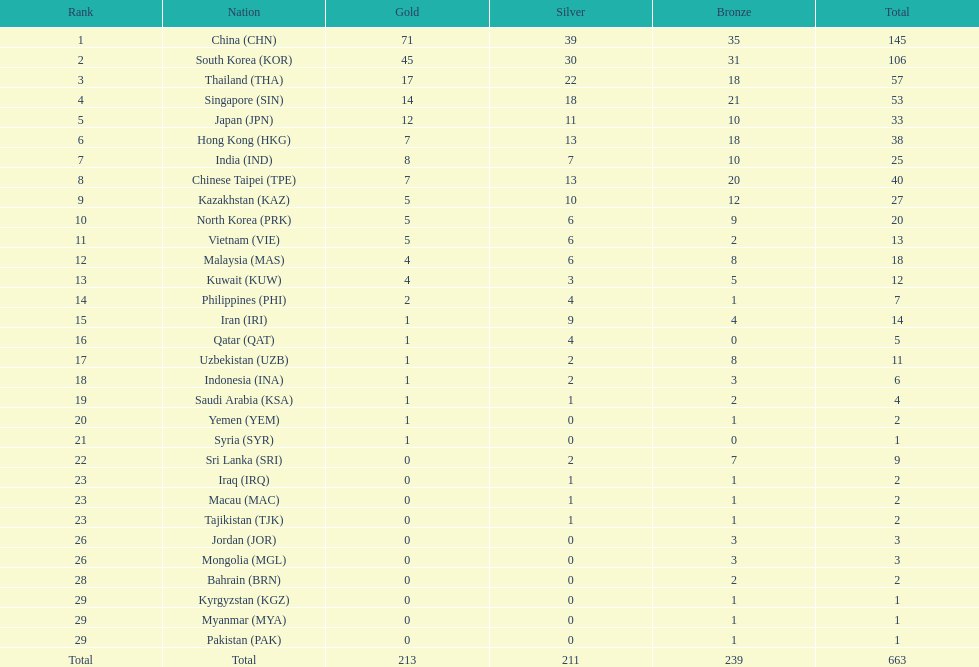Parse the full table. {'header': ['Rank', 'Nation', 'Gold', 'Silver', 'Bronze', 'Total'], 'rows': [['1', 'China\xa0(CHN)', '71', '39', '35', '145'], ['2', 'South Korea\xa0(KOR)', '45', '30', '31', '106'], ['3', 'Thailand\xa0(THA)', '17', '22', '18', '57'], ['4', 'Singapore\xa0(SIN)', '14', '18', '21', '53'], ['5', 'Japan\xa0(JPN)', '12', '11', '10', '33'], ['6', 'Hong Kong\xa0(HKG)', '7', '13', '18', '38'], ['7', 'India\xa0(IND)', '8', '7', '10', '25'], ['8', 'Chinese Taipei\xa0(TPE)', '7', '13', '20', '40'], ['9', 'Kazakhstan\xa0(KAZ)', '5', '10', '12', '27'], ['10', 'North Korea\xa0(PRK)', '5', '6', '9', '20'], ['11', 'Vietnam\xa0(VIE)', '5', '6', '2', '13'], ['12', 'Malaysia\xa0(MAS)', '4', '6', '8', '18'], ['13', 'Kuwait\xa0(KUW)', '4', '3', '5', '12'], ['14', 'Philippines\xa0(PHI)', '2', '4', '1', '7'], ['15', 'Iran\xa0(IRI)', '1', '9', '4', '14'], ['16', 'Qatar\xa0(QAT)', '1', '4', '0', '5'], ['17', 'Uzbekistan\xa0(UZB)', '1', '2', '8', '11'], ['18', 'Indonesia\xa0(INA)', '1', '2', '3', '6'], ['19', 'Saudi Arabia\xa0(KSA)', '1', '1', '2', '4'], ['20', 'Yemen\xa0(YEM)', '1', '0', '1', '2'], ['21', 'Syria\xa0(SYR)', '1', '0', '0', '1'], ['22', 'Sri Lanka\xa0(SRI)', '0', '2', '7', '9'], ['23', 'Iraq\xa0(IRQ)', '0', '1', '1', '2'], ['23', 'Macau\xa0(MAC)', '0', '1', '1', '2'], ['23', 'Tajikistan\xa0(TJK)', '0', '1', '1', '2'], ['26', 'Jordan\xa0(JOR)', '0', '0', '3', '3'], ['26', 'Mongolia\xa0(MGL)', '0', '0', '3', '3'], ['28', 'Bahrain\xa0(BRN)', '0', '0', '2', '2'], ['29', 'Kyrgyzstan\xa0(KGZ)', '0', '0', '1', '1'], ['29', 'Myanmar\xa0(MYA)', '0', '0', '1', '1'], ['29', 'Pakistan\xa0(PAK)', '0', '0', '1', '1'], ['Total', 'Total', '213', '211', '239', '663']]} How many nations earned at least ten bronze medals? 9. 